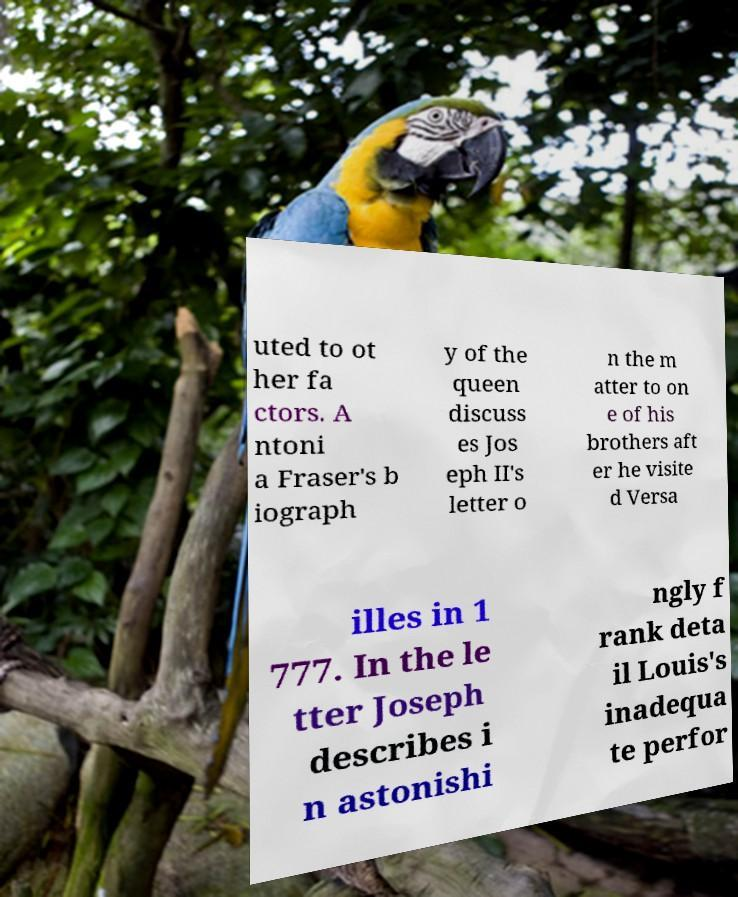I need the written content from this picture converted into text. Can you do that? uted to ot her fa ctors. A ntoni a Fraser's b iograph y of the queen discuss es Jos eph II's letter o n the m atter to on e of his brothers aft er he visite d Versa illes in 1 777. In the le tter Joseph describes i n astonishi ngly f rank deta il Louis's inadequa te perfor 